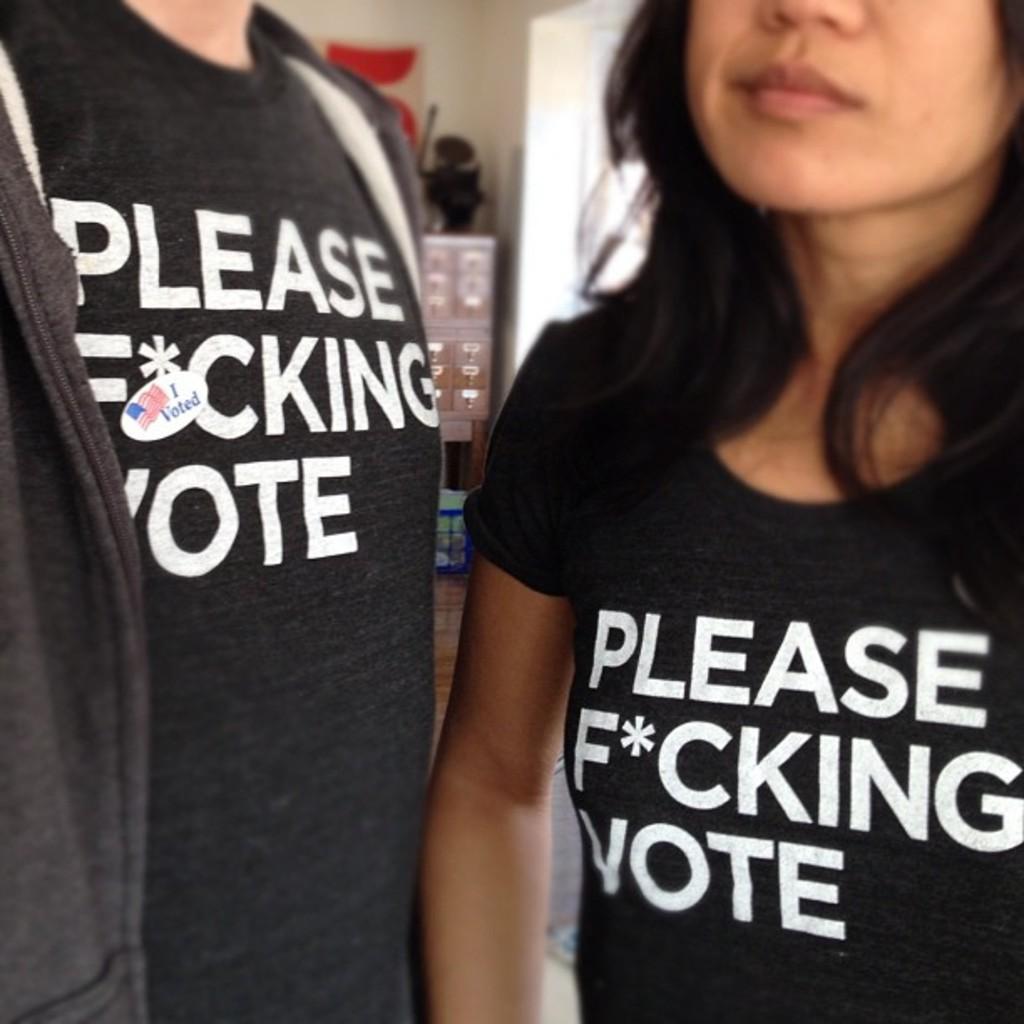What does the man's sticker say?
Your response must be concise. I voted. 